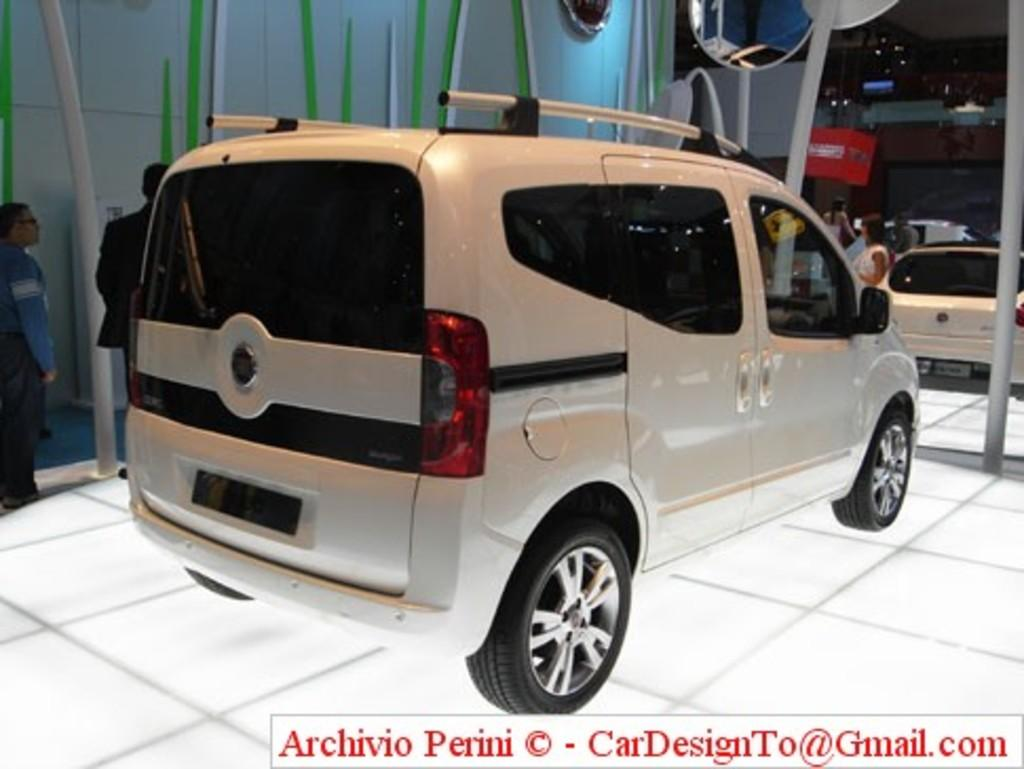What type of vehicles can be seen in the image? There are cars in the image. What are the people in the image doing? There are people standing in the image. Can you describe the unique object in the image? There is a mirror attached to a pole in the image. Where is the text located in the image? The text is at the bottom right corner of the image. How many zebras can be seen crossing the road in the image? There are no zebras or roads present in the image. What is the base material of the mirror in the image? The base material of the mirror is not mentioned in the image, as it only shows the mirror attached to a pole. 